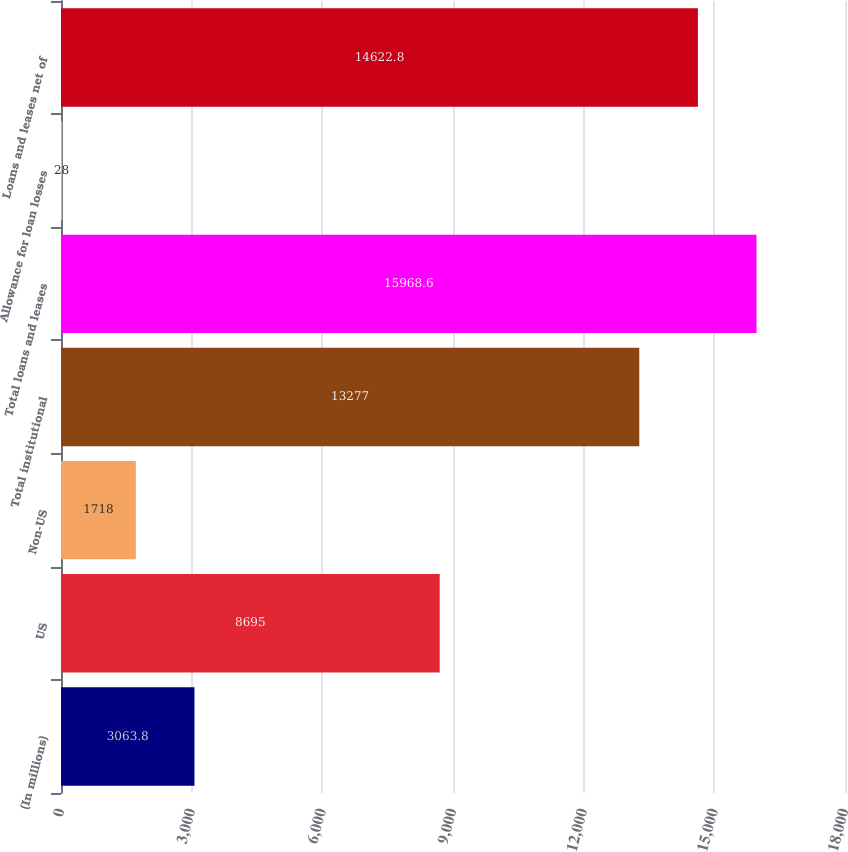<chart> <loc_0><loc_0><loc_500><loc_500><bar_chart><fcel>(In millions)<fcel>US<fcel>Non-US<fcel>Total institutional<fcel>Total loans and leases<fcel>Allowance for loan losses<fcel>Loans and leases net of<nl><fcel>3063.8<fcel>8695<fcel>1718<fcel>13277<fcel>15968.6<fcel>28<fcel>14622.8<nl></chart> 